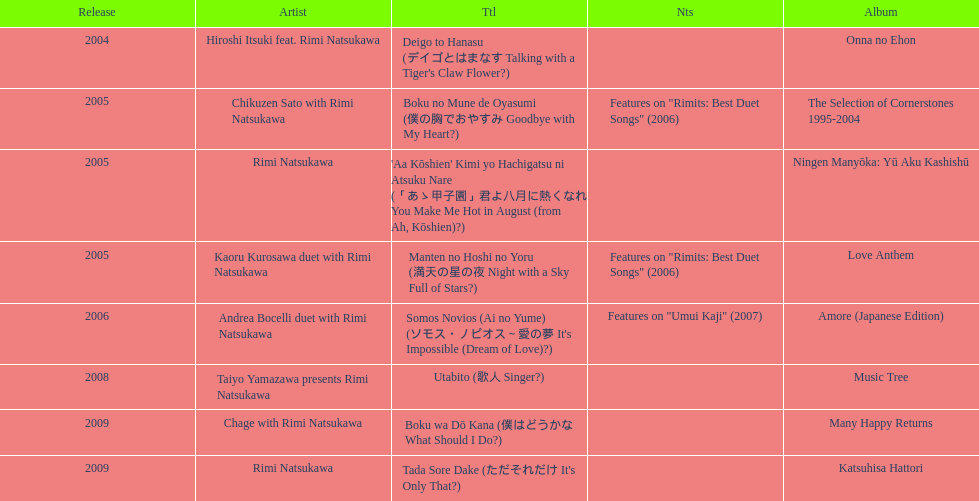What was the album released immediately before the one that had boku wa do kana on it? Music Tree. 